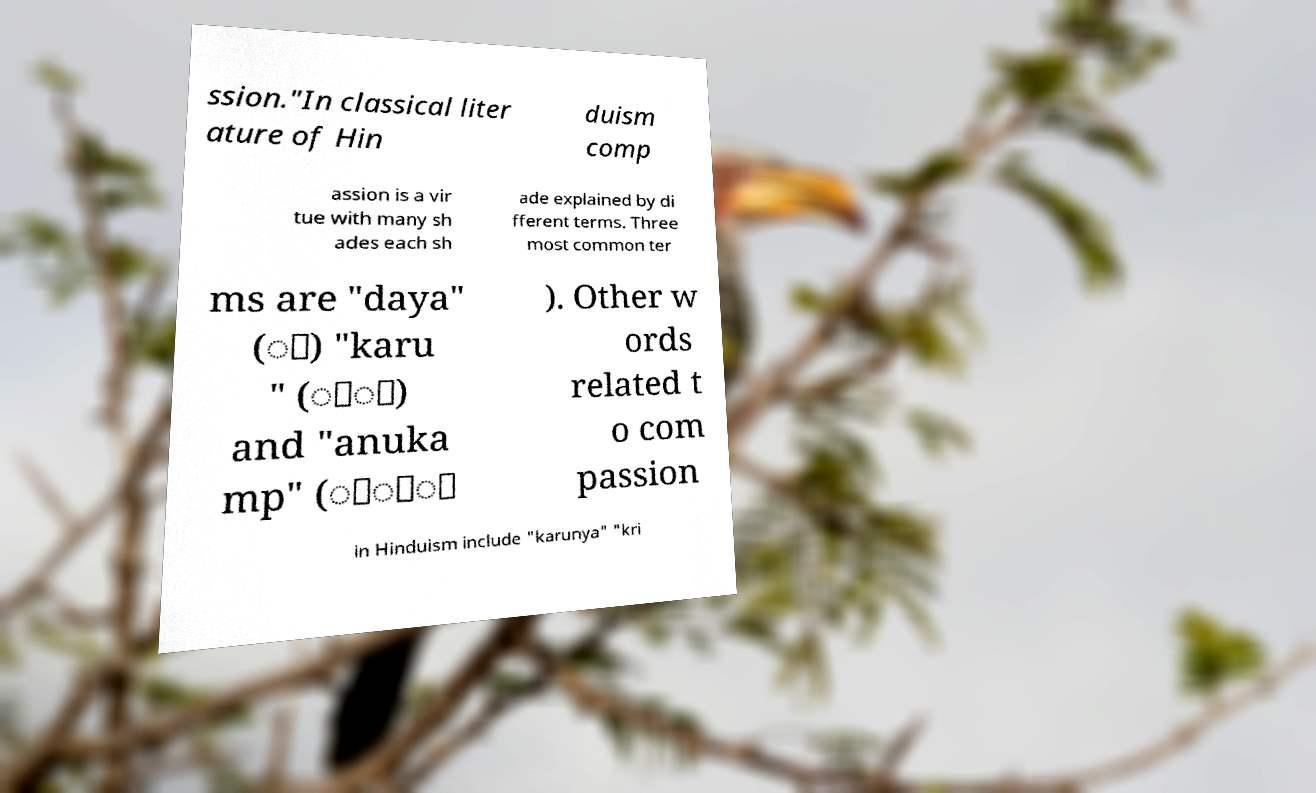Please identify and transcribe the text found in this image. ssion."In classical liter ature of Hin duism comp assion is a vir tue with many sh ades each sh ade explained by di fferent terms. Three most common ter ms are "daya" (ा) "karu " (ुा) and "anuka mp" (ु्ा ). Other w ords related t o com passion in Hinduism include "karunya" "kri 